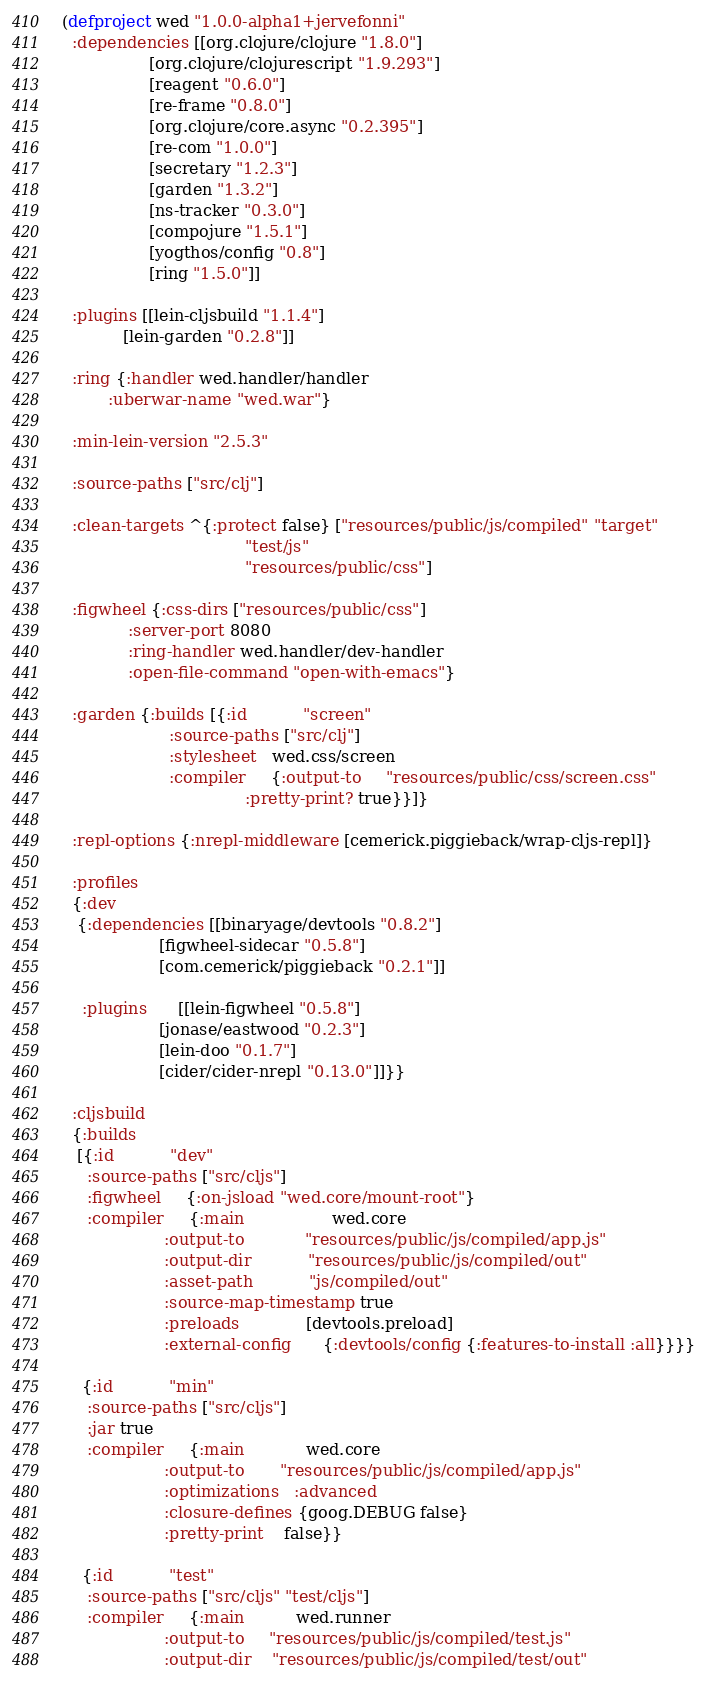<code> <loc_0><loc_0><loc_500><loc_500><_Clojure_>(defproject wed "1.0.0-alpha1+jervefonni"
  :dependencies [[org.clojure/clojure "1.8.0"]
                 [org.clojure/clojurescript "1.9.293"]
                 [reagent "0.6.0"]
                 [re-frame "0.8.0"]
                 [org.clojure/core.async "0.2.395"]
                 [re-com "1.0.0"]
                 [secretary "1.2.3"]
                 [garden "1.3.2"]
                 [ns-tracker "0.3.0"]
                 [compojure "1.5.1"]
                 [yogthos/config "0.8"]
                 [ring "1.5.0"]]

  :plugins [[lein-cljsbuild "1.1.4"]
            [lein-garden "0.2.8"]]

  :ring {:handler wed.handler/handler
         :uberwar-name "wed.war"}

  :min-lein-version "2.5.3"

  :source-paths ["src/clj"]

  :clean-targets ^{:protect false} ["resources/public/js/compiled" "target"
                                    "test/js"
                                    "resources/public/css"]

  :figwheel {:css-dirs ["resources/public/css"]
             :server-port 8080
             :ring-handler wed.handler/dev-handler
             :open-file-command "open-with-emacs"}

  :garden {:builds [{:id           "screen"
                     :source-paths ["src/clj"]
                     :stylesheet   wed.css/screen
                     :compiler     {:output-to     "resources/public/css/screen.css"
                                    :pretty-print? true}}]}

  :repl-options {:nrepl-middleware [cemerick.piggieback/wrap-cljs-repl]}

  :profiles
  {:dev
   {:dependencies [[binaryage/devtools "0.8.2"]
                   [figwheel-sidecar "0.5.8"]
                   [com.cemerick/piggieback "0.2.1"]]

    :plugins      [[lein-figwheel "0.5.8"]
                   [jonase/eastwood "0.2.3"]
                   [lein-doo "0.1.7"]
                   [cider/cider-nrepl "0.13.0"]]}}

  :cljsbuild
  {:builds
   [{:id           "dev"
     :source-paths ["src/cljs"]
     :figwheel     {:on-jsload "wed.core/mount-root"}
     :compiler     {:main                 wed.core
                    :output-to            "resources/public/js/compiled/app.js"
                    :output-dir           "resources/public/js/compiled/out"
                    :asset-path           "js/compiled/out"
                    :source-map-timestamp true
                    :preloads             [devtools.preload]
                    :external-config      {:devtools/config {:features-to-install :all}}}}

    {:id           "min"
     :source-paths ["src/cljs"]
     :jar true
     :compiler     {:main            wed.core
                    :output-to       "resources/public/js/compiled/app.js"
                    :optimizations   :advanced
                    :closure-defines {goog.DEBUG false}
                    :pretty-print    false}}

    {:id           "test"
     :source-paths ["src/cljs" "test/cljs"]
     :compiler     {:main          wed.runner
                    :output-to     "resources/public/js/compiled/test.js"
                    :output-dir    "resources/public/js/compiled/test/out"</code> 